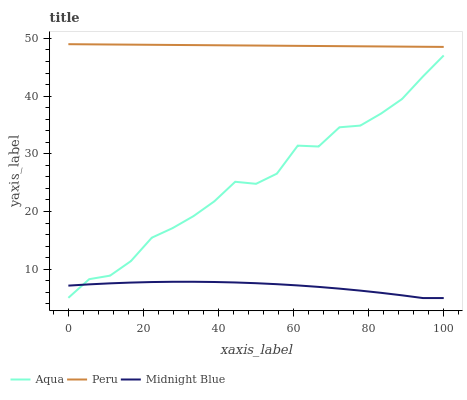Does Midnight Blue have the minimum area under the curve?
Answer yes or no. Yes. Does Peru have the maximum area under the curve?
Answer yes or no. Yes. Does Peru have the minimum area under the curve?
Answer yes or no. No. Does Midnight Blue have the maximum area under the curve?
Answer yes or no. No. Is Peru the smoothest?
Answer yes or no. Yes. Is Aqua the roughest?
Answer yes or no. Yes. Is Midnight Blue the smoothest?
Answer yes or no. No. Is Midnight Blue the roughest?
Answer yes or no. No. Does Midnight Blue have the lowest value?
Answer yes or no. Yes. Does Peru have the lowest value?
Answer yes or no. No. Does Peru have the highest value?
Answer yes or no. Yes. Does Midnight Blue have the highest value?
Answer yes or no. No. Is Midnight Blue less than Peru?
Answer yes or no. Yes. Is Peru greater than Aqua?
Answer yes or no. Yes. Does Midnight Blue intersect Aqua?
Answer yes or no. Yes. Is Midnight Blue less than Aqua?
Answer yes or no. No. Is Midnight Blue greater than Aqua?
Answer yes or no. No. Does Midnight Blue intersect Peru?
Answer yes or no. No. 